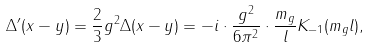<formula> <loc_0><loc_0><loc_500><loc_500>\Delta ^ { \prime } ( x - y ) = \frac { 2 } { 3 } g ^ { 2 } \Delta ( x - y ) = - i \cdot \frac { g ^ { 2 } } { 6 \pi ^ { 2 } } \cdot \frac { m _ { g } } { l } K _ { - 1 } ( m _ { g } l ) ,</formula> 